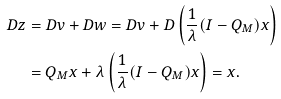<formula> <loc_0><loc_0><loc_500><loc_500>D z & = D v + D w = D v + D \left ( \frac { 1 } { \lambda } ( I - Q _ { M } ) x \right ) \\ & = Q _ { M } x + \lambda \left ( \frac { 1 } { \lambda } ( I - Q _ { M } ) x \right ) = x .</formula> 